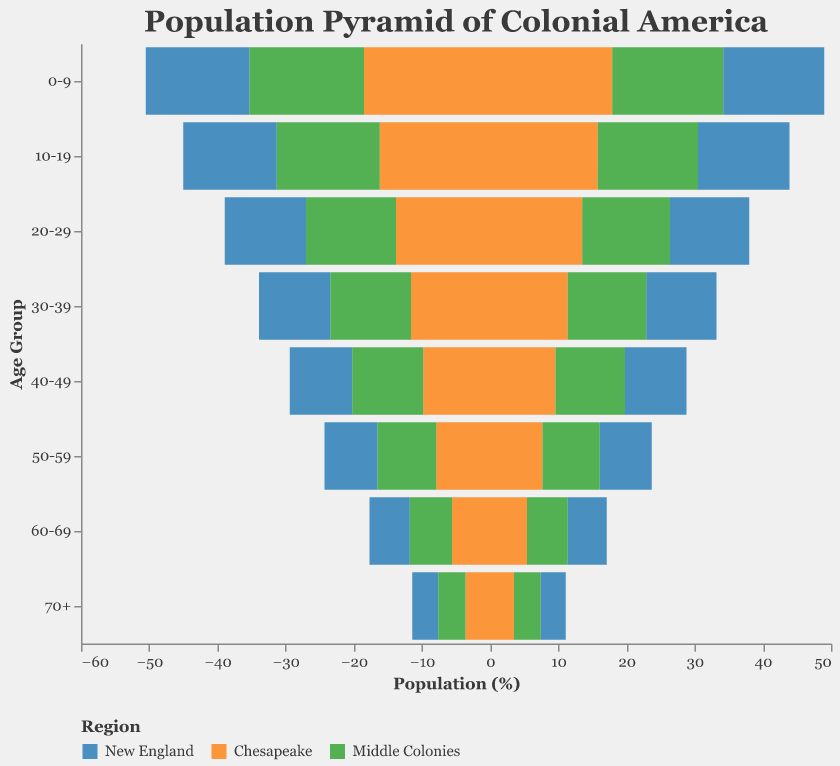What is the percentage of males aged 0-9 in the Chesapeake region? To find this value, look at the portion of the pyramid representing males in the 0-9 age group under the Chesapeake region. The corresponding value is 18.5%.
Answer: 18.5% What age group has the highest percentage of females in the New England region? To identify this, examine the female segments of the pyramid specific to the New England region. The highest percentage for females in New England is in the 0-9 age group, which is 14.8%.
Answer: 0-9 Which region has the largest percentage of males in the 30-39 age group? Compare the percentages of males aged 30-39 across New England, Chesapeake, and Middle Colonies regions. The Middle Colonies have the highest percentage of males in this age group at 11.8%.
Answer: Middle Colonies What is the difference in percentages between males and females aged 20-29 in the Chesapeake region? Identify the values for males and females aged 20-29 in the Chesapeake region: males (13.8%) and females (13.5%). The difference is calculated as 13.8% - 13.5% = 0.3%.
Answer: 0.3% What is the percentage of the population aged 50-59 in the Middle Colonies region? To find the percentage of the population aged 50-59 in the Middle Colonies, sum the values for both males (8.6%) and females (8.4%) in this age group. Therefore, 8.6% + 8.4% = 17%.
Answer: 17% Which age group has the smallest percentage of people in the New England region? Examine the pyramid for the New England region to determine the age group with the lowest combined percentage of males and females. The smallest percentage in New England is the 70+ age group, with males at 3.8% and females at 3.7%.
Answer: 70+ Between the Chesapeake and Middle Colonies regions, which one has more females in the 40-49 age group? Compare the percentages of females aged 40-49: Chesapeake (9.6%) and Middle Colonies (10.2%). The Middle Colonies have a higher percentage of females in this age group.
Answer: Middle Colonies What is the combined percentage of males aged 60-69 across all regions? To find this, sum the values of males aged 60-69 in New England (5.9%), Chesapeake (5.6%), and Middle Colonies (6.2%). The combined percentage is 5.9% + 5.6% + 6.2% = 17.7%.
Answer: 17.7% 